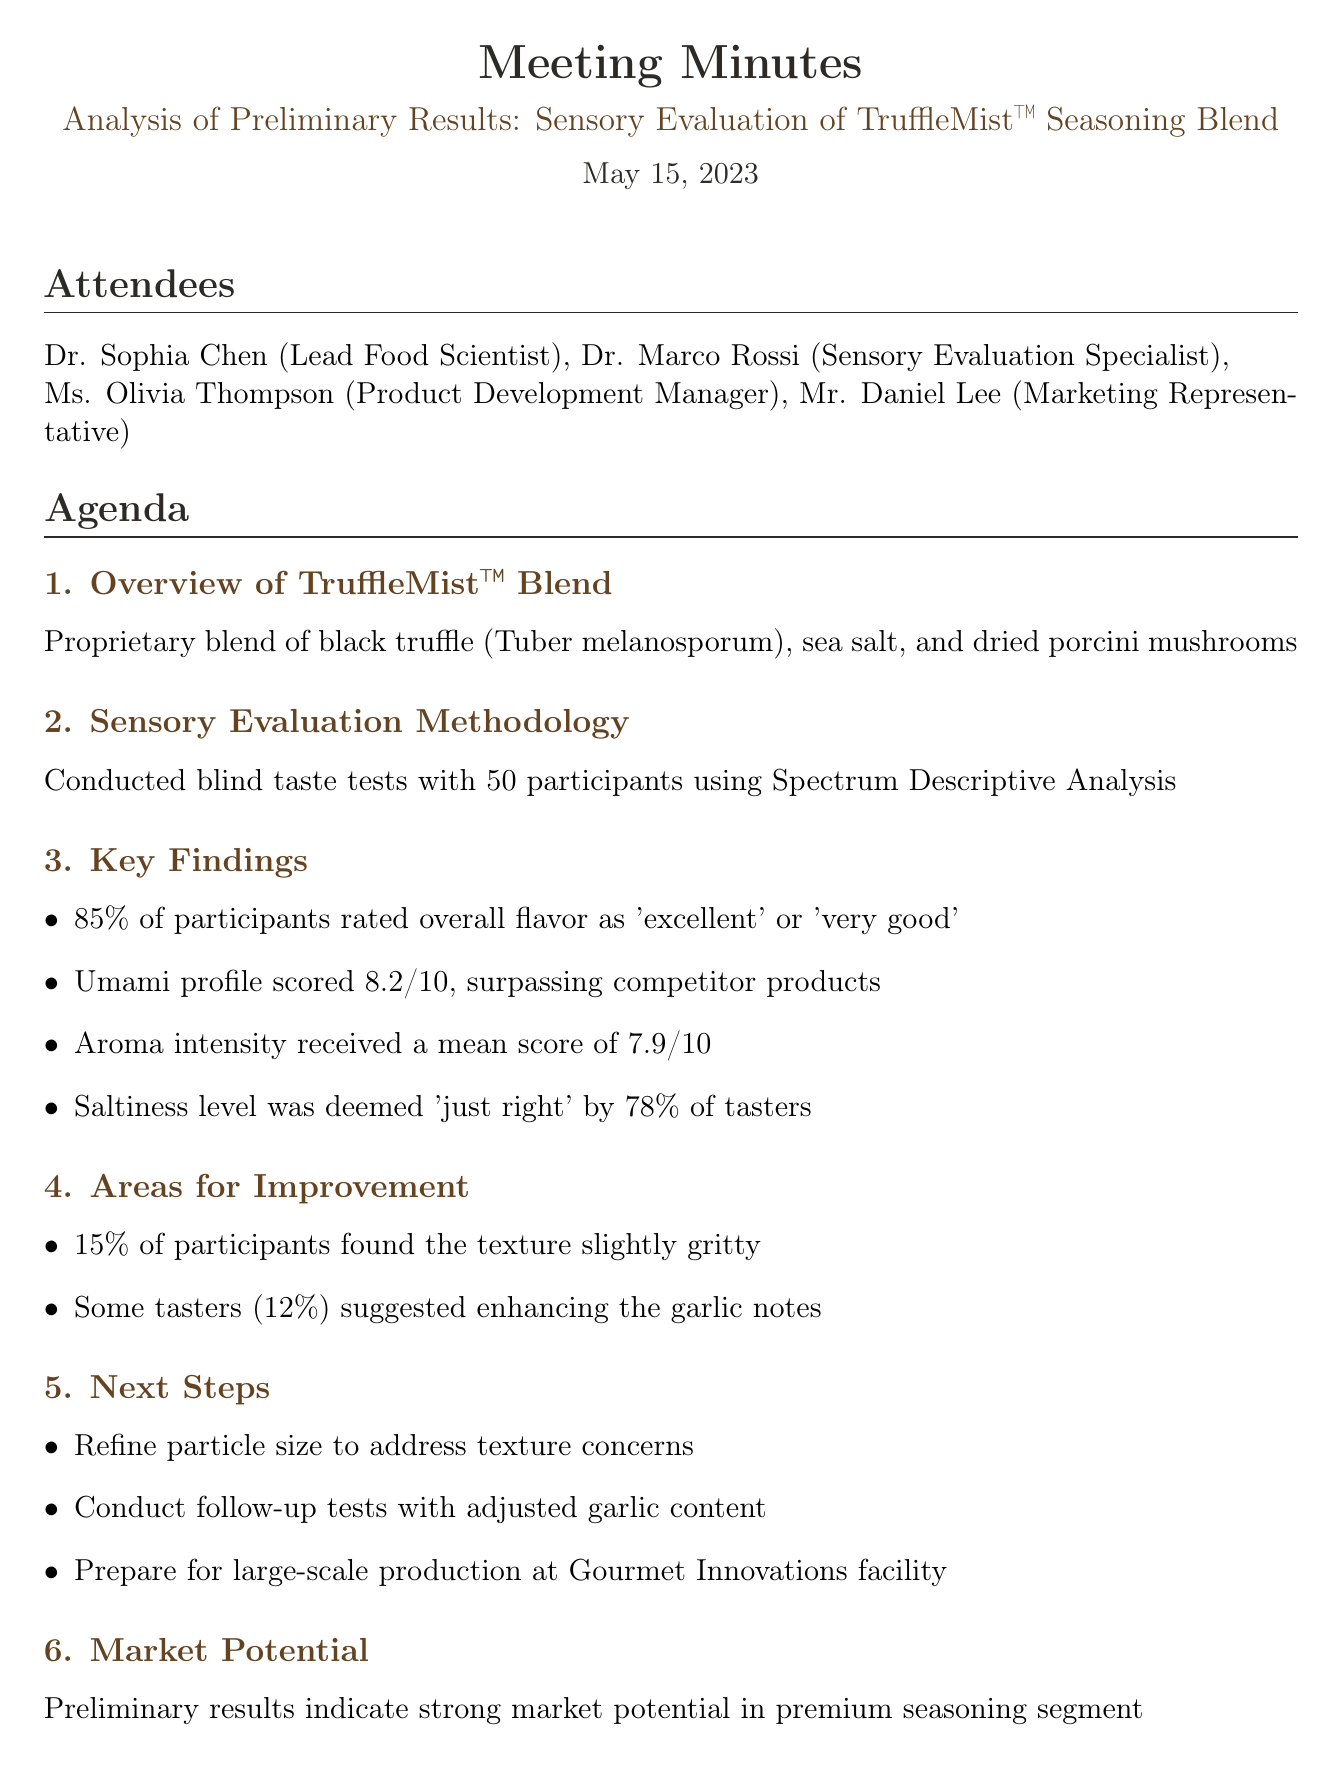What is the date of the meeting? The date of the meeting is specified at the beginning of the document, which is May 15, 2023.
Answer: May 15, 2023 Who is the Lead Food Scientist? The attendees section lists Dr. Sophia Chen as the Lead Food Scientist.
Answer: Dr. Sophia Chen What percentage of participants rated the overall flavor as 'excellent' or 'very good'? The key findings section states that 85% of participants rated the overall flavor positively.
Answer: 85% What score did the Umami profile receive? The key findings provide the Umami profile score, which is 8.2 out of 10.
Answer: 8.2/10 What area for improvement was noted regarding texture? The areas for improvement section mentions that 15% of participants found the texture slightly gritty.
Answer: Slightly gritty Which task is assigned to Dr. Marco Rossi? The action items list shows that scheduling follow-up sensory tests is assigned to Dr. Marco Rossi.
Answer: Schedule follow-up sensory tests What is the deadline for adjusting the formulation? The action items section specifies May 31, 2023, as the deadline for the formulation adjustment task.
Answer: May 31, 2023 What are the next steps regarding particle size? The next steps include refining particle size to address the texture concerns as listed in the document.
Answer: Refine particle size Is there an indication of market potential for the new seasoning blend? The market potential section reveals that there is strong market potential in the premium seasoning segment.
Answer: Strong market potential 